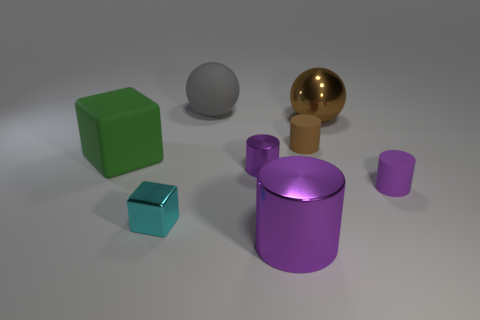Are there fewer tiny purple shiny cylinders than blue metal blocks?
Offer a terse response. No. What size is the thing that is in front of the small purple shiny cylinder and on the left side of the gray sphere?
Ensure brevity in your answer.  Small. There is a purple shiny object behind the purple metallic cylinder in front of the small matte object that is on the right side of the large metal ball; how big is it?
Your answer should be very brief. Small. What number of other things are the same color as the big cylinder?
Keep it short and to the point. 2. Does the tiny matte cylinder that is on the right side of the tiny brown cylinder have the same color as the small cube?
Keep it short and to the point. No. What number of things are either small brown rubber things or big red cylinders?
Your answer should be very brief. 1. What color is the tiny object to the left of the gray rubber object?
Give a very brief answer. Cyan. Are there fewer green rubber things behind the big green block than objects?
Your answer should be compact. Yes. There is another metal cylinder that is the same color as the tiny metal cylinder; what size is it?
Give a very brief answer. Large. Is there anything else that has the same size as the brown shiny ball?
Give a very brief answer. Yes. 